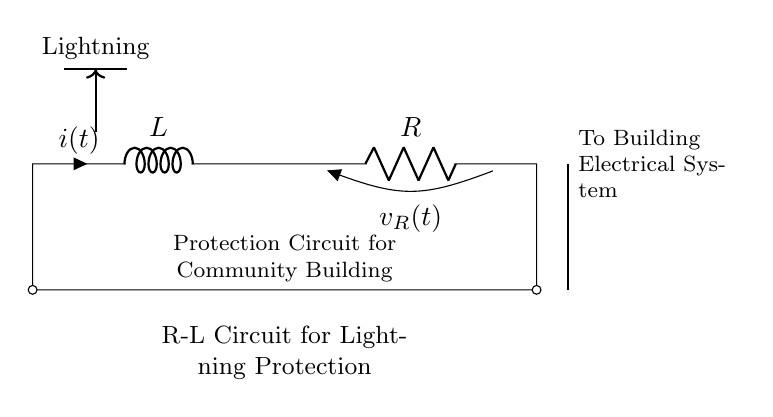What is the value of the inductor in this circuit? The circuit diagram indicates the inductor is identified as L, but there is no specific numerical value provided in the diagram. Therefore, we cannot ascertain its exact value based on the visual.
Answer: L What component is used for current resistance in this circuit? The component used for current resistance in this circuit is labeled as R in the diagram. It represents a resistor, which is essential for limiting current flow.
Answer: R Which way does the current flow through the inductor? The current through the inductor is indicated as i(t), and the arrow shows that it flows from left to right in the circuit as denoted in the diagram.
Answer: Left to right What is the main function of this R-L circuit? The main function of the R-L circuit, as indicated by the description, is lightning protection for a community building. This suggests that it is designed to manage and mitigate the effects of lightning strikes.
Answer: Lightning protection How are the components connected in this circuit? The components are connected in series; the current flows through the inductor first and then through the resistor sequentially before returning to the starting point. This configuration is evident in the straight connection lines without any branches.
Answer: In series What is the voltage across the resistor indicated as in the diagram? The voltage across the resistor is labeled as v_R(t), showing that it is a variable voltage depending on the current flow and resistance according to Ohm’s law.
Answer: v_R(t) What type of circuit is depicted in this diagram? The circuit is specifically a resistor-inductor (R-L) circuit, as both a resistor (R) and an inductor (L) are present, which are characteristic elements of R-L circuits.
Answer: Resistor-Inductor 